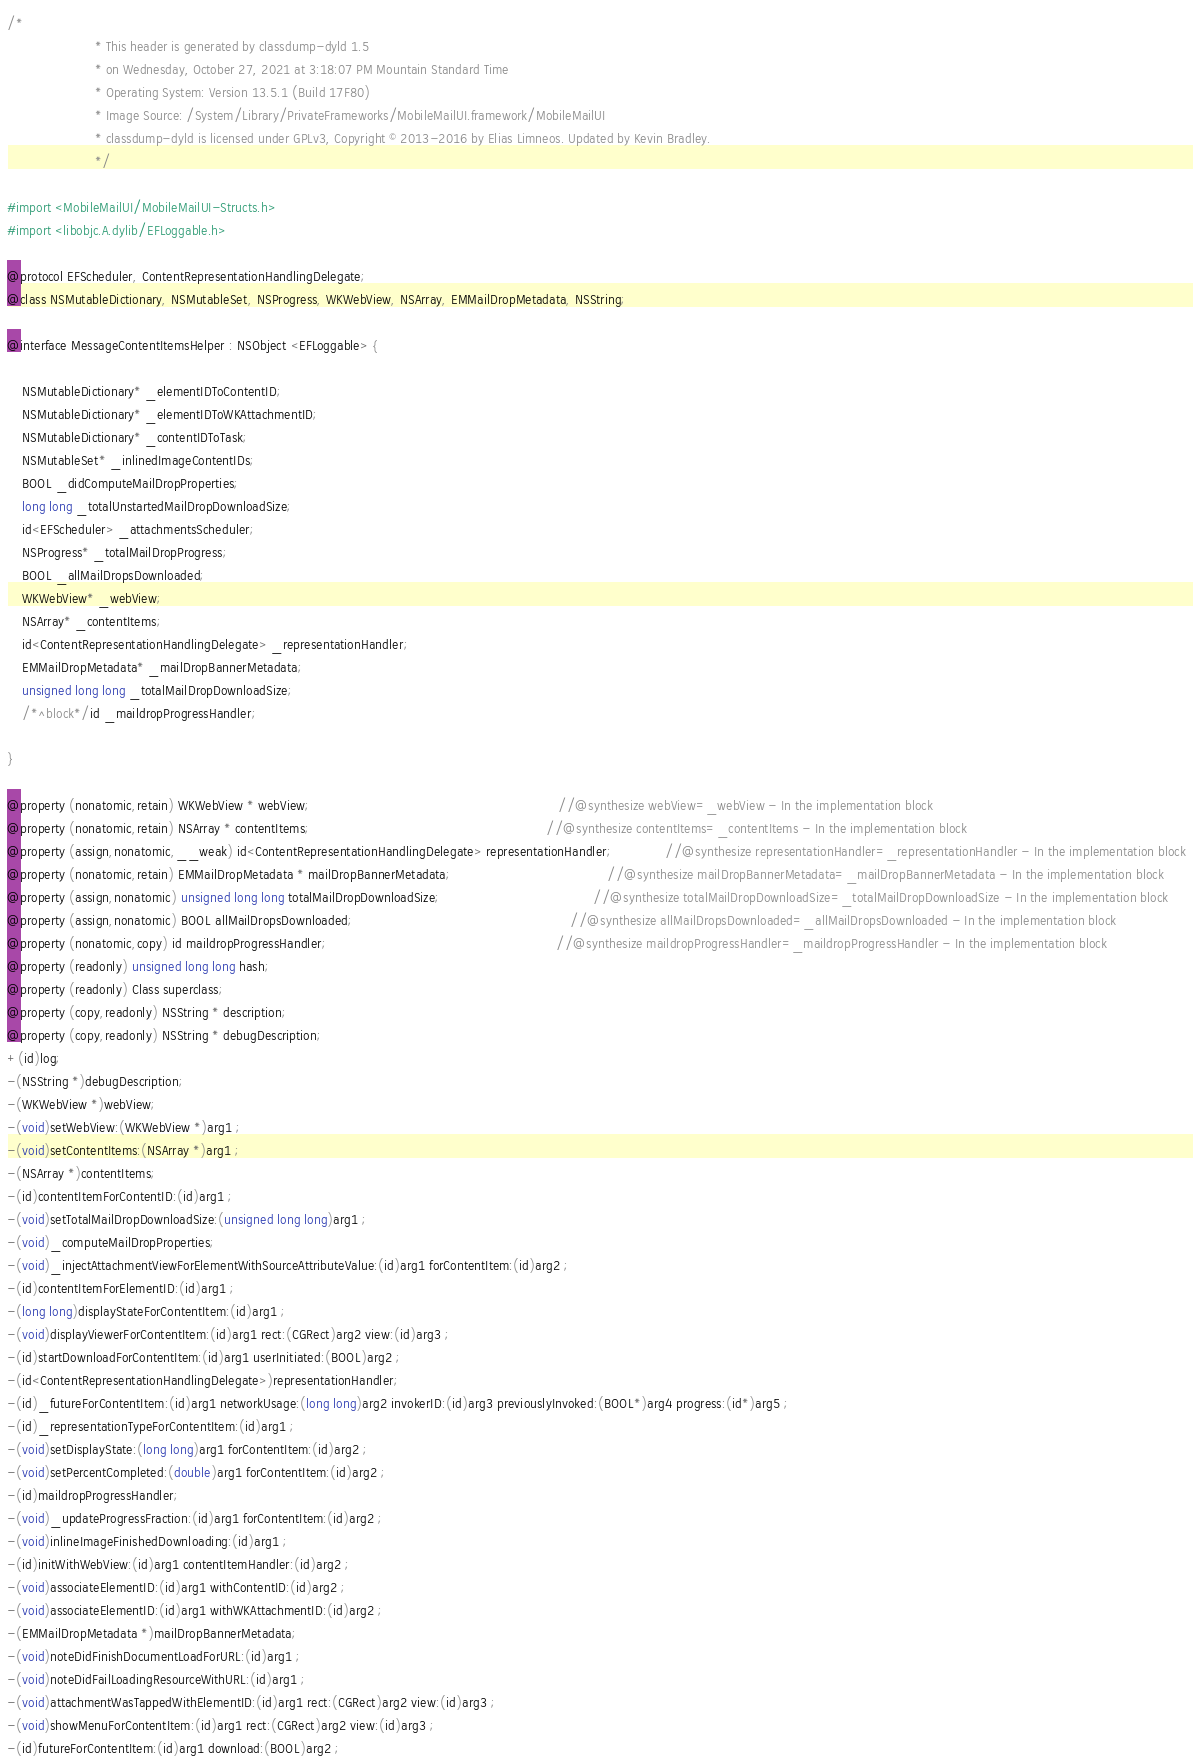Convert code to text. <code><loc_0><loc_0><loc_500><loc_500><_C_>/*
                       * This header is generated by classdump-dyld 1.5
                       * on Wednesday, October 27, 2021 at 3:18:07 PM Mountain Standard Time
                       * Operating System: Version 13.5.1 (Build 17F80)
                       * Image Source: /System/Library/PrivateFrameworks/MobileMailUI.framework/MobileMailUI
                       * classdump-dyld is licensed under GPLv3, Copyright © 2013-2016 by Elias Limneos. Updated by Kevin Bradley.
                       */

#import <MobileMailUI/MobileMailUI-Structs.h>
#import <libobjc.A.dylib/EFLoggable.h>

@protocol EFScheduler, ContentRepresentationHandlingDelegate;
@class NSMutableDictionary, NSMutableSet, NSProgress, WKWebView, NSArray, EMMailDropMetadata, NSString;

@interface MessageContentItemsHelper : NSObject <EFLoggable> {

	NSMutableDictionary* _elementIDToContentID;
	NSMutableDictionary* _elementIDToWKAttachmentID;
	NSMutableDictionary* _contentIDToTask;
	NSMutableSet* _inlinedImageContentIDs;
	BOOL _didComputeMailDropProperties;
	long long _totalUnstartedMailDropDownloadSize;
	id<EFScheduler> _attachmentsScheduler;
	NSProgress* _totalMailDropProgress;
	BOOL _allMailDropsDownloaded;
	WKWebView* _webView;
	NSArray* _contentItems;
	id<ContentRepresentationHandlingDelegate> _representationHandler;
	EMMailDropMetadata* _mailDropBannerMetadata;
	unsigned long long _totalMailDropDownloadSize;
	/*^block*/id _maildropProgressHandler;

}

@property (nonatomic,retain) WKWebView * webView;                                                                 //@synthesize webView=_webView - In the implementation block
@property (nonatomic,retain) NSArray * contentItems;                                                              //@synthesize contentItems=_contentItems - In the implementation block
@property (assign,nonatomic,__weak) id<ContentRepresentationHandlingDelegate> representationHandler;              //@synthesize representationHandler=_representationHandler - In the implementation block
@property (nonatomic,retain) EMMailDropMetadata * mailDropBannerMetadata;                                         //@synthesize mailDropBannerMetadata=_mailDropBannerMetadata - In the implementation block
@property (assign,nonatomic) unsigned long long totalMailDropDownloadSize;                                        //@synthesize totalMailDropDownloadSize=_totalMailDropDownloadSize - In the implementation block
@property (assign,nonatomic) BOOL allMailDropsDownloaded;                                                         //@synthesize allMailDropsDownloaded=_allMailDropsDownloaded - In the implementation block
@property (nonatomic,copy) id maildropProgressHandler;                                                            //@synthesize maildropProgressHandler=_maildropProgressHandler - In the implementation block
@property (readonly) unsigned long long hash; 
@property (readonly) Class superclass; 
@property (copy,readonly) NSString * description; 
@property (copy,readonly) NSString * debugDescription; 
+(id)log;
-(NSString *)debugDescription;
-(WKWebView *)webView;
-(void)setWebView:(WKWebView *)arg1 ;
-(void)setContentItems:(NSArray *)arg1 ;
-(NSArray *)contentItems;
-(id)contentItemForContentID:(id)arg1 ;
-(void)setTotalMailDropDownloadSize:(unsigned long long)arg1 ;
-(void)_computeMailDropProperties;
-(void)_injectAttachmentViewForElementWithSourceAttributeValue:(id)arg1 forContentItem:(id)arg2 ;
-(id)contentItemForElementID:(id)arg1 ;
-(long long)displayStateForContentItem:(id)arg1 ;
-(void)displayViewerForContentItem:(id)arg1 rect:(CGRect)arg2 view:(id)arg3 ;
-(id)startDownloadForContentItem:(id)arg1 userInitiated:(BOOL)arg2 ;
-(id<ContentRepresentationHandlingDelegate>)representationHandler;
-(id)_futureForContentItem:(id)arg1 networkUsage:(long long)arg2 invokerID:(id)arg3 previouslyInvoked:(BOOL*)arg4 progress:(id*)arg5 ;
-(id)_representationTypeForContentItem:(id)arg1 ;
-(void)setDisplayState:(long long)arg1 forContentItem:(id)arg2 ;
-(void)setPercentCompleted:(double)arg1 forContentItem:(id)arg2 ;
-(id)maildropProgressHandler;
-(void)_updateProgressFraction:(id)arg1 forContentItem:(id)arg2 ;
-(void)inlineImageFinishedDownloading:(id)arg1 ;
-(id)initWithWebView:(id)arg1 contentItemHandler:(id)arg2 ;
-(void)associateElementID:(id)arg1 withContentID:(id)arg2 ;
-(void)associateElementID:(id)arg1 withWKAttachmentID:(id)arg2 ;
-(EMMailDropMetadata *)mailDropBannerMetadata;
-(void)noteDidFinishDocumentLoadForURL:(id)arg1 ;
-(void)noteDidFailLoadingResourceWithURL:(id)arg1 ;
-(void)attachmentWasTappedWithElementID:(id)arg1 rect:(CGRect)arg2 view:(id)arg3 ;
-(void)showMenuForContentItem:(id)arg1 rect:(CGRect)arg2 view:(id)arg3 ;
-(id)futureForContentItem:(id)arg1 download:(BOOL)arg2 ;</code> 